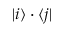Convert formula to latex. <formula><loc_0><loc_0><loc_500><loc_500>| i \rangle \cdot \langle j |</formula> 